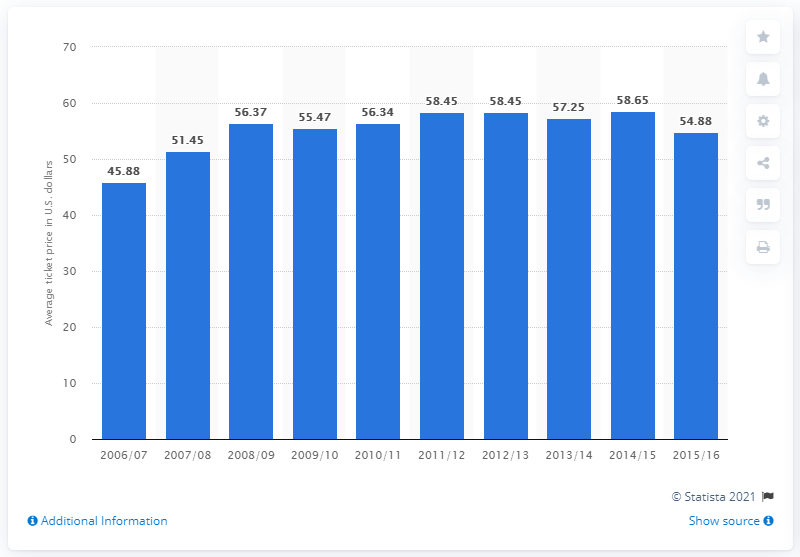Highlight a few significant elements in this photo. In the 2006/2007 season, the average ticket price for San Antonio Spurs games was approximately 45.88 U.S. dollars. 